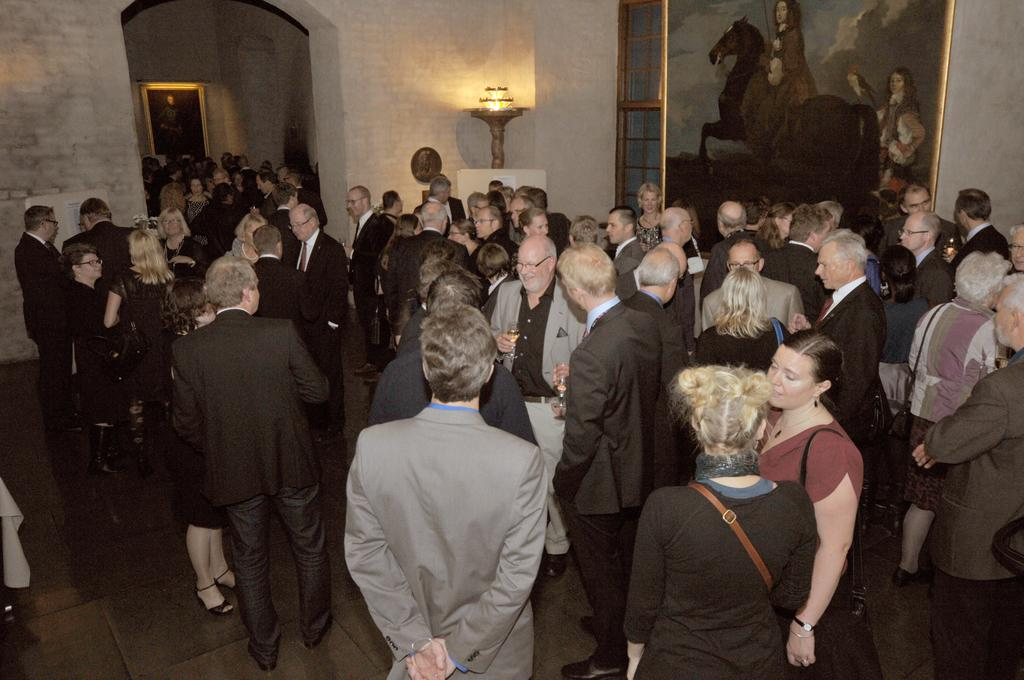What is the main subject of the image? The main subject of the image is a crowd of people. What can be observed about the people in the crowd? The people in the crowd are wearing clothes. What is located at the top of the image? There is a light at the top of the image. What type of artwork is present in the image? There is a painting in the top right of the image. Can you describe the volcano erupting in the background of the image? There is no volcano present in the image; it features a crowd of people, a light, and a painting. What type of pig is depicted in the painting in the image? There is no pig depicted in the painting in the image; the painting's content cannot be determined from the provided facts. 